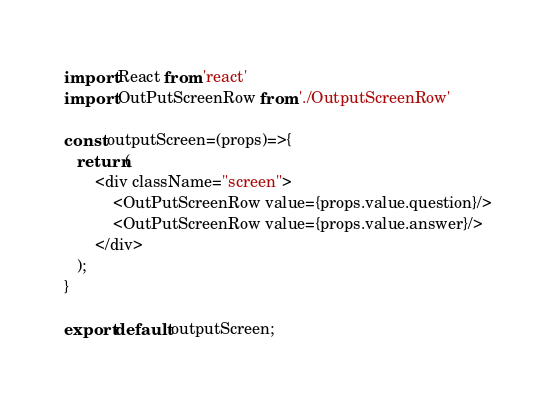Convert code to text. <code><loc_0><loc_0><loc_500><loc_500><_JavaScript_>import React from 'react'
import OutPutScreenRow from './OutputScreenRow'

const outputScreen=(props)=>{
   return(
       <div className="screen">
           <OutPutScreenRow value={props.value.question}/>
           <OutPutScreenRow value={props.value.answer}/>
       </div>
   );
}

export default outputScreen;</code> 